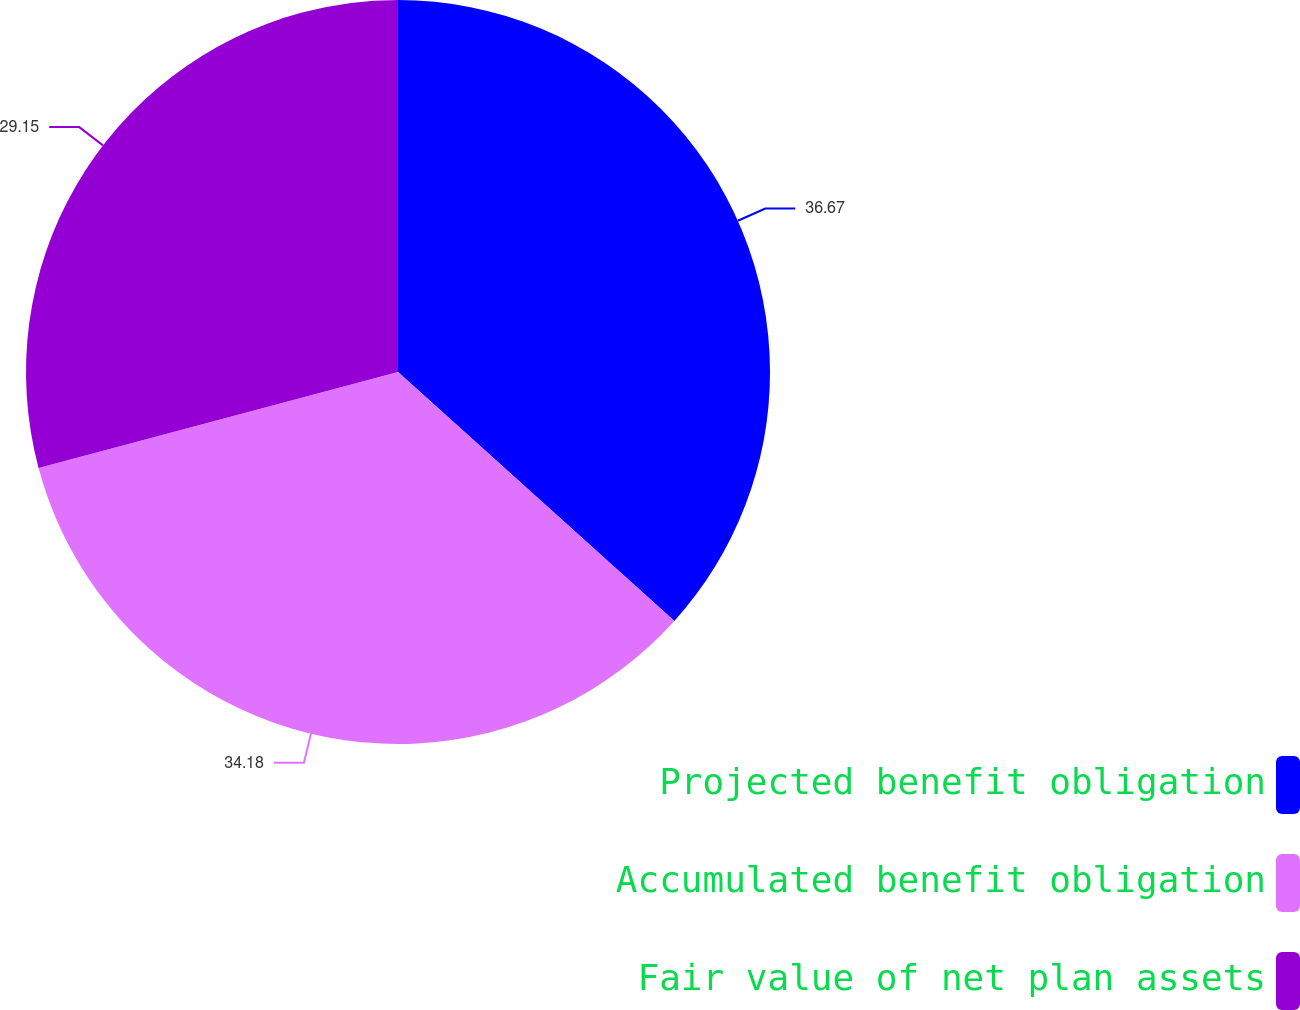Convert chart. <chart><loc_0><loc_0><loc_500><loc_500><pie_chart><fcel>Projected benefit obligation<fcel>Accumulated benefit obligation<fcel>Fair value of net plan assets<nl><fcel>36.67%<fcel>34.18%<fcel>29.15%<nl></chart> 